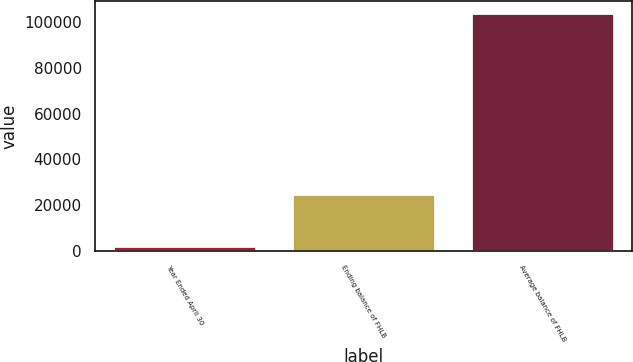Convert chart to OTSL. <chart><loc_0><loc_0><loc_500><loc_500><bar_chart><fcel>Year Ended April 30<fcel>Ending balance of FHLB<fcel>Average balance of FHLB<nl><fcel>2009<fcel>25000<fcel>103885<nl></chart> 